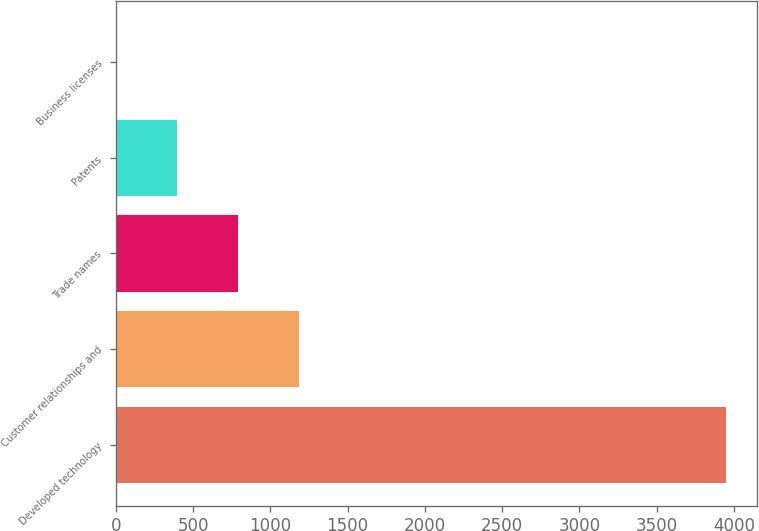Convert chart to OTSL. <chart><loc_0><loc_0><loc_500><loc_500><bar_chart><fcel>Developed technology<fcel>Customer relationships and<fcel>Trade names<fcel>Patents<fcel>Business licenses<nl><fcel>3951.1<fcel>1187.15<fcel>792.3<fcel>397.45<fcel>2.6<nl></chart> 